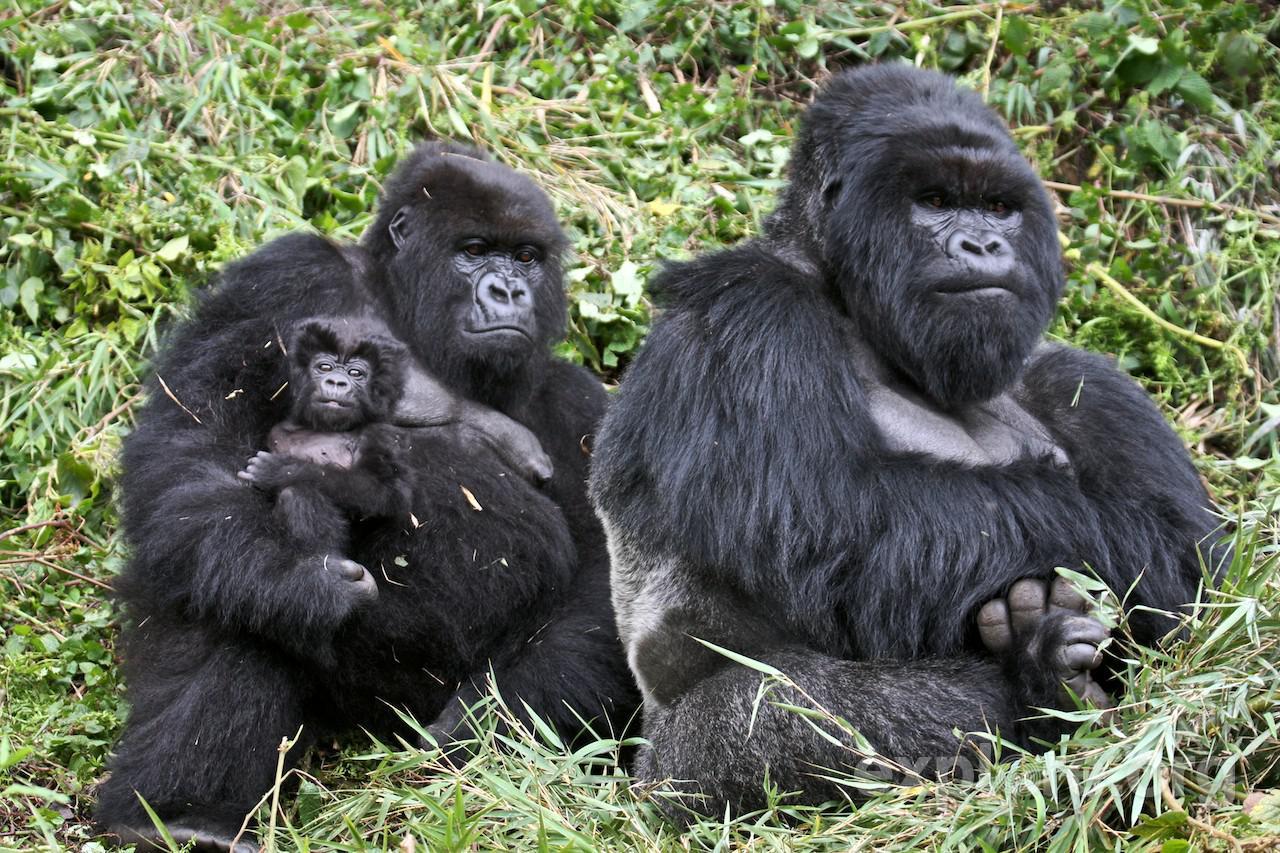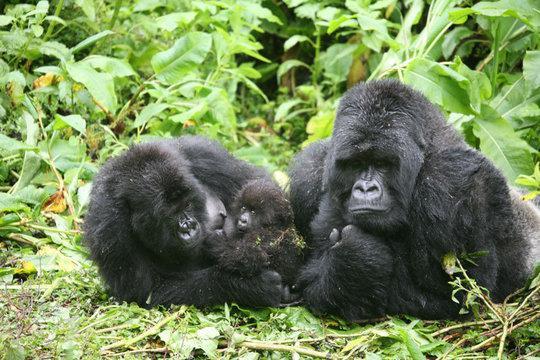The first image is the image on the left, the second image is the image on the right. Assess this claim about the two images: "At least one of the photos contains three or more apes.". Correct or not? Answer yes or no. Yes. The first image is the image on the left, the second image is the image on the right. For the images displayed, is the sentence "The left image depicts only one adult ape, which has an arm around a younger ape." factually correct? Answer yes or no. No. 